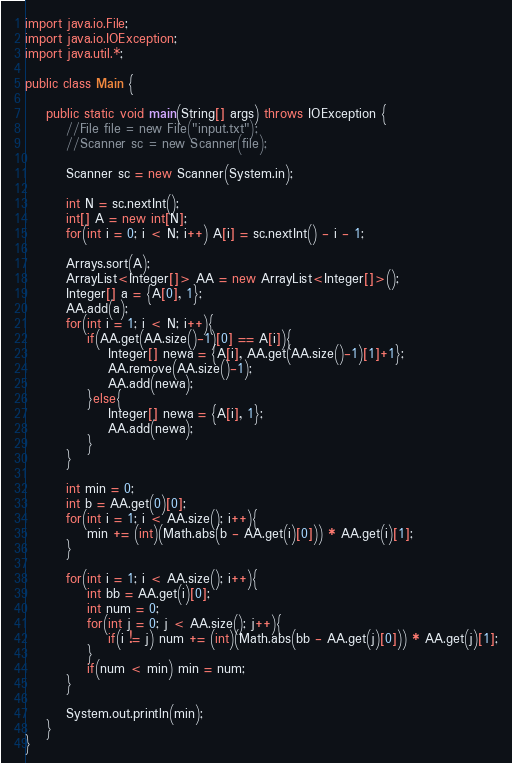<code> <loc_0><loc_0><loc_500><loc_500><_Java_>import java.io.File;
import java.io.IOException;
import java.util.*;
 
public class Main {
 
	public static void main(String[] args) throws IOException {
		//File file = new File("input.txt");
		//Scanner sc = new Scanner(file);
		
		Scanner sc = new Scanner(System.in);
		
		int N = sc.nextInt();
		int[] A = new int[N];
		for(int i = 0; i < N; i++) A[i] = sc.nextInt() - i - 1;
		
		Arrays.sort(A);
		ArrayList<Integer[]> AA = new ArrayList<Integer[]>();
		Integer[] a = {A[0], 1};
		AA.add(a);
		for(int i = 1; i < N; i++){
			if(AA.get(AA.size()-1)[0] == A[i]){
				Integer[] newa = {A[i], AA.get(AA.size()-1)[1]+1};
				AA.remove(AA.size()-1);
				AA.add(newa);
			}else{
				Integer[] newa = {A[i], 1};
				AA.add(newa);
			}
		}
		
		int min = 0;
		int b = AA.get(0)[0];
		for(int i = 1; i < AA.size(); i++){
			min += (int)(Math.abs(b - AA.get(i)[0])) * AA.get(i)[1];
		}
		
		for(int i = 1; i < AA.size(); i++){
			int bb = AA.get(i)[0];
			int num = 0;
			for(int j = 0; j < AA.size(); j++){
				if(i != j) num += (int)(Math.abs(bb - AA.get(j)[0])) * AA.get(j)[1];
			}
			if(num < min) min = num;
		}
		
		System.out.println(min);
	}
}</code> 